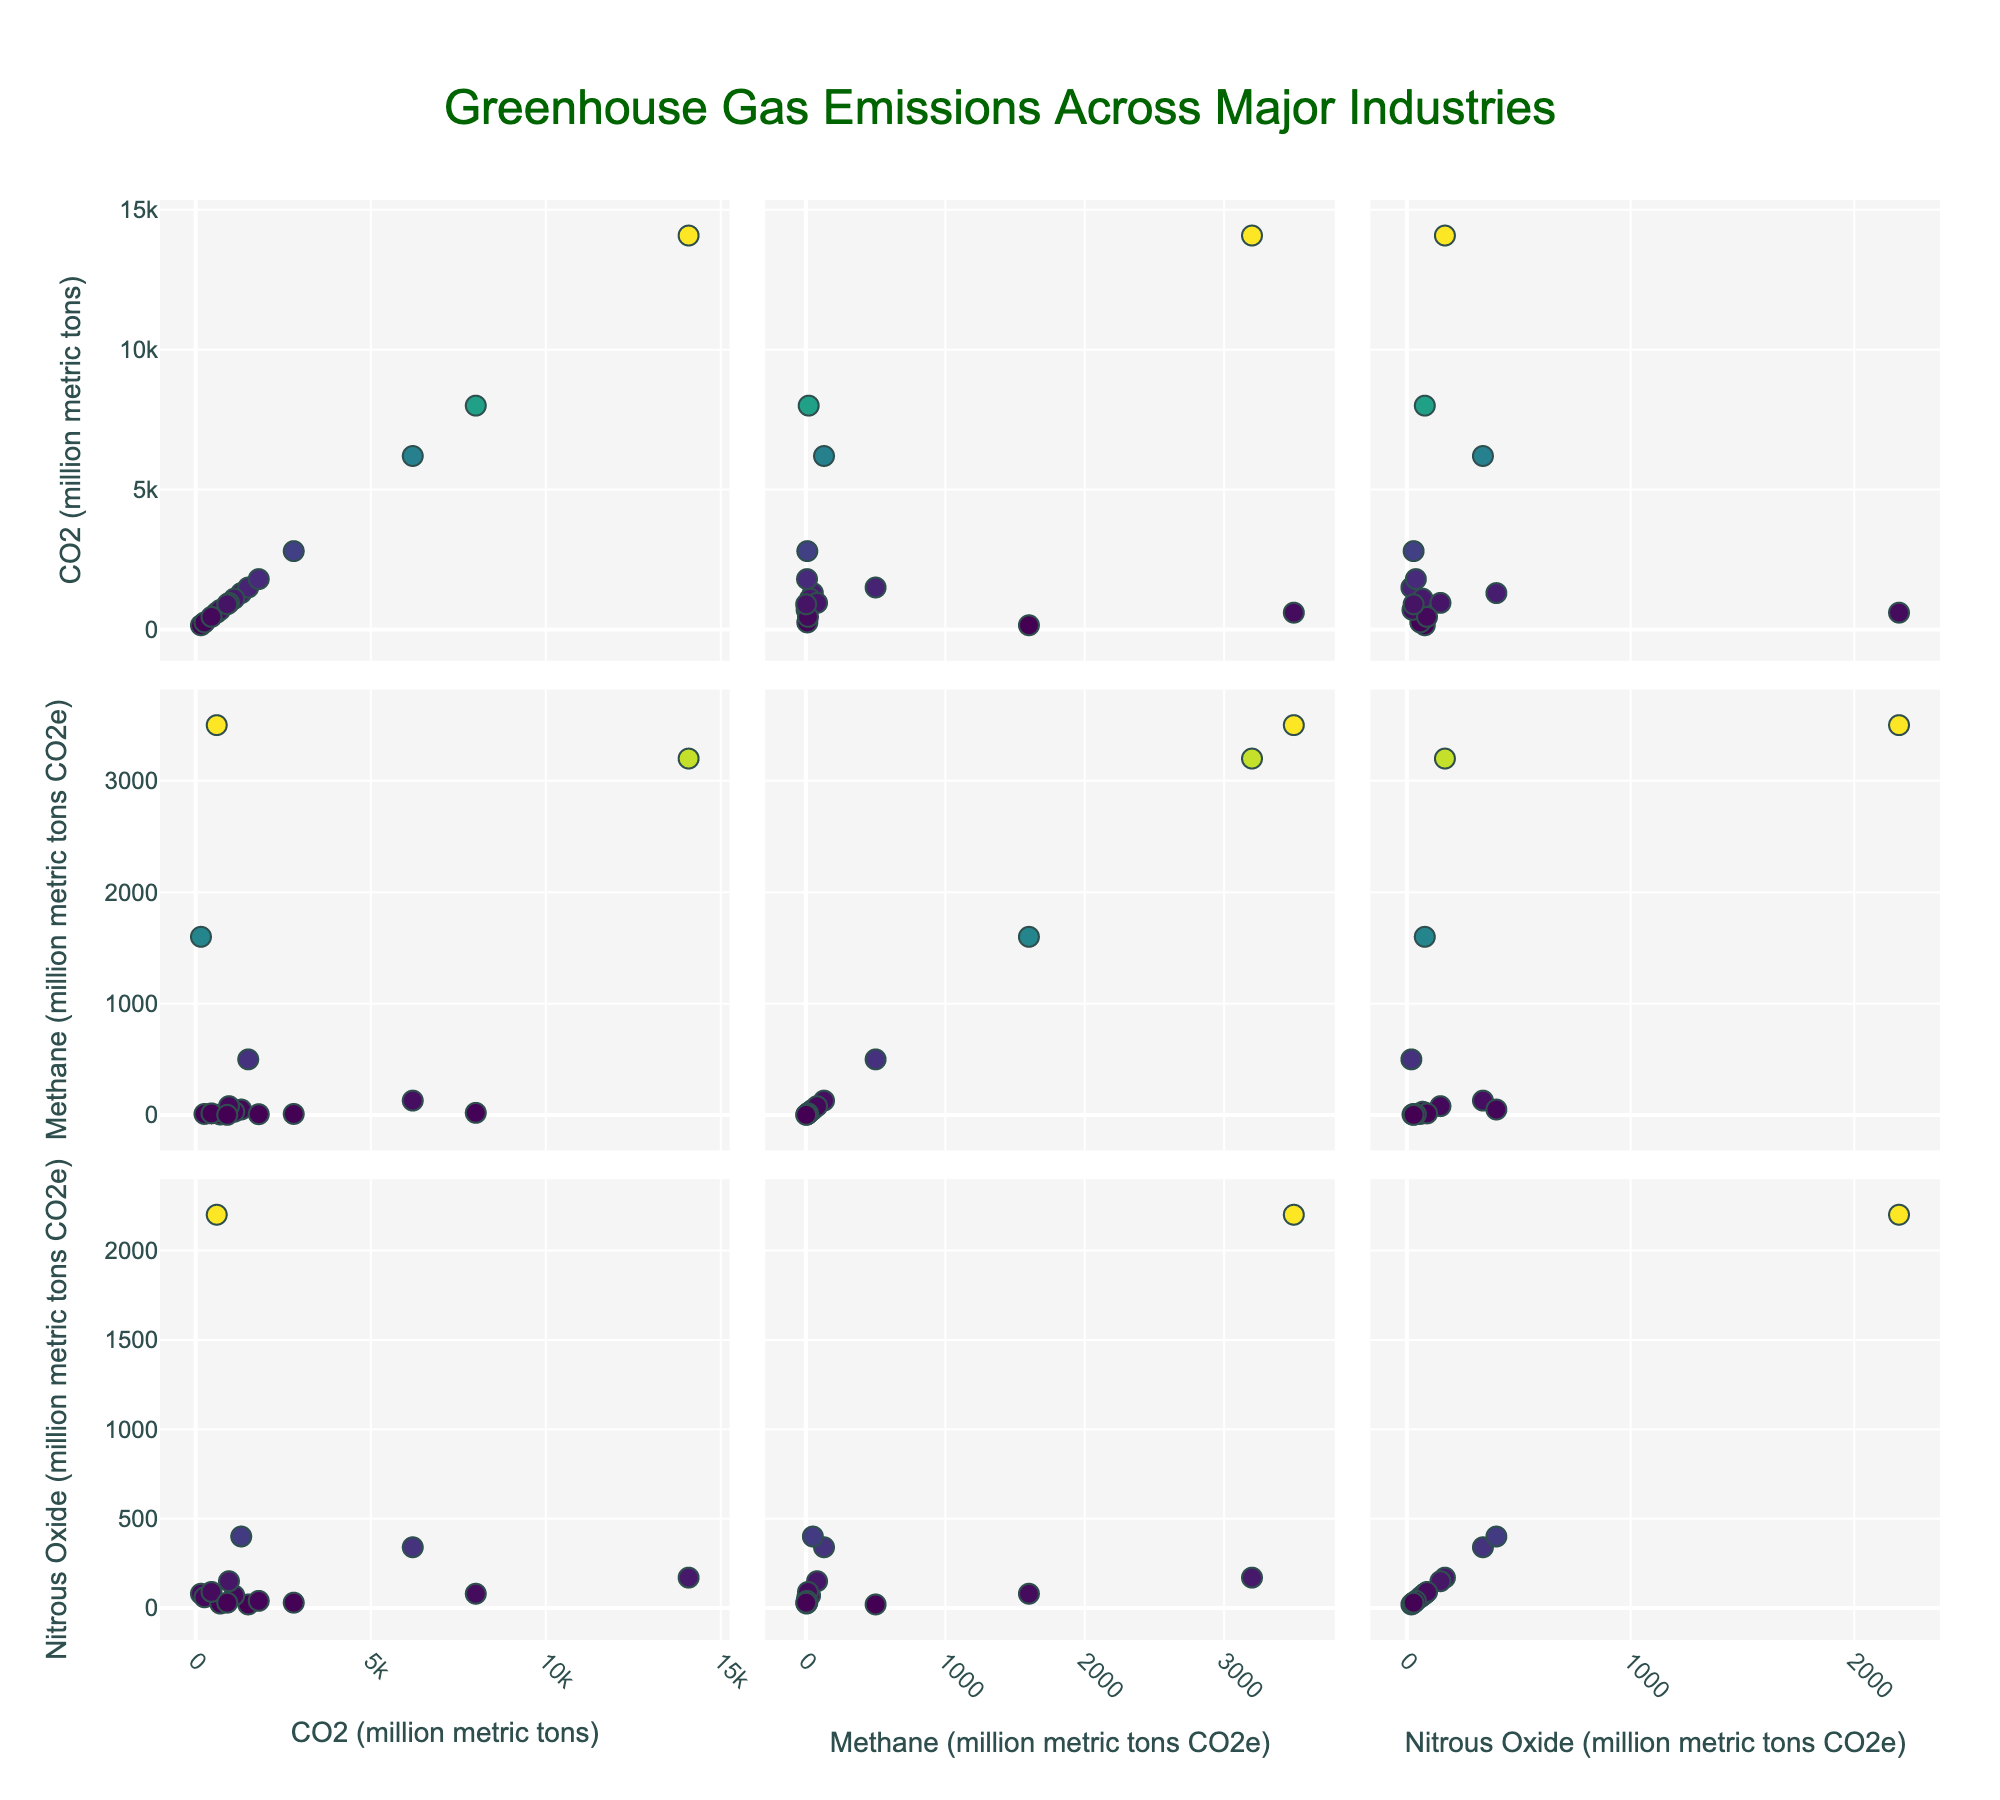What's the title of the figure? The title is typically located at the top center of the figure and it summarizes the main focus of the plot.
Answer: Greenhouse Gas Emissions Across Major Industries How many data points are there for each variable in the scatterplot matrix? Each industry's emissions data for CO2, methane, and nitrous oxide represent one data point. Given that there are 15 industries mentioned, there will be 15 data points for each variable.
Answer: 15 Which industry shows the highest methane emissions? By inspecting the scatter plots where 'Methane (million metric tons CO2e)' is on the x-axis and looking for the highest value, the Agriculture industry shows the highest value.
Answer: Agriculture Which two industries have similar levels of CO2 emissions but different levels of methane emissions? By looking at the scatter plot where 'CO2 (million metric tons)' is plotted against 'Methane (million metric tons CO2e)', we observe that the Manufacturing and Transportation industries have similar CO2 emissions but Transportation has much lower methane emissions.
Answer: Manufacturing and Transportation What's the relationship between CO2 and nitrous oxide emissions in the Energy industry? By locating the Energy industry data point in the scatter plots where CO2 and Nitrous Oxide are on the x and y axes, respectively, we observe there's a corresponding high CO2 emission (14080 million metric tons) with a relatively lower nitrous oxide emission (170 million metric tons CO2e).
Answer: High CO2, Low Nitrous Oxide How does Agricultural methane emissions compare to all other industries on the scatter plot? By inspecting the scatter plots where 'Methane (million metric tons CO2e)' is on the axis, Agriculture shows the highest methane emissions in comparison to other industries, often appearing as an outlier or significantly higher point.
Answer: Considerably higher Which industry has lower CO2 emissions but higher nitrous oxide emissions compared to Energy industry? By examining the scatter plots, it is shown that Agriculture has much lower CO2 emissions (600 million metric tons) but higher nitrous oxide emissions (2200 million metric tons CO2e).
Answer: Agriculture What are the average methane emissions across all the industries? Adding all the methane emission values across the data points and dividing by the number of industries (3500 + 3200 + 130 + 20 + 10 + 1600 + 50 + 500 + 10 + 5 + 30 + 80 + 15 + 8 + 2 = 9190) and then dividing by 15 gives the average. (9190 / 15 = 612.67)
Answer: 612.67 In the context of the scatterplot matrix, explain how the emissions in the Transportation industry compare with those of the Energy industry for CO2 and methane. By looking at the scatter plots, the Transportation industry has lower CO2 emissions (8000) compared to Energy (14080) but also significantly lower methane emissions (20 compared to 3200). Both reductions are evident in the plot locations.
Answer: Lower for both Which industry shows negligible methane emissions and relatively low CO2 and nitrous oxide emissions? By observing the placement of data points, Forestry stands out with negligible methane emissions (10 million metric tons CO2e), and both its CO2 (250 million metric tons) and nitrous oxide emissions (60 million metric tons CO2e) are also low.
Answer: Forestry 